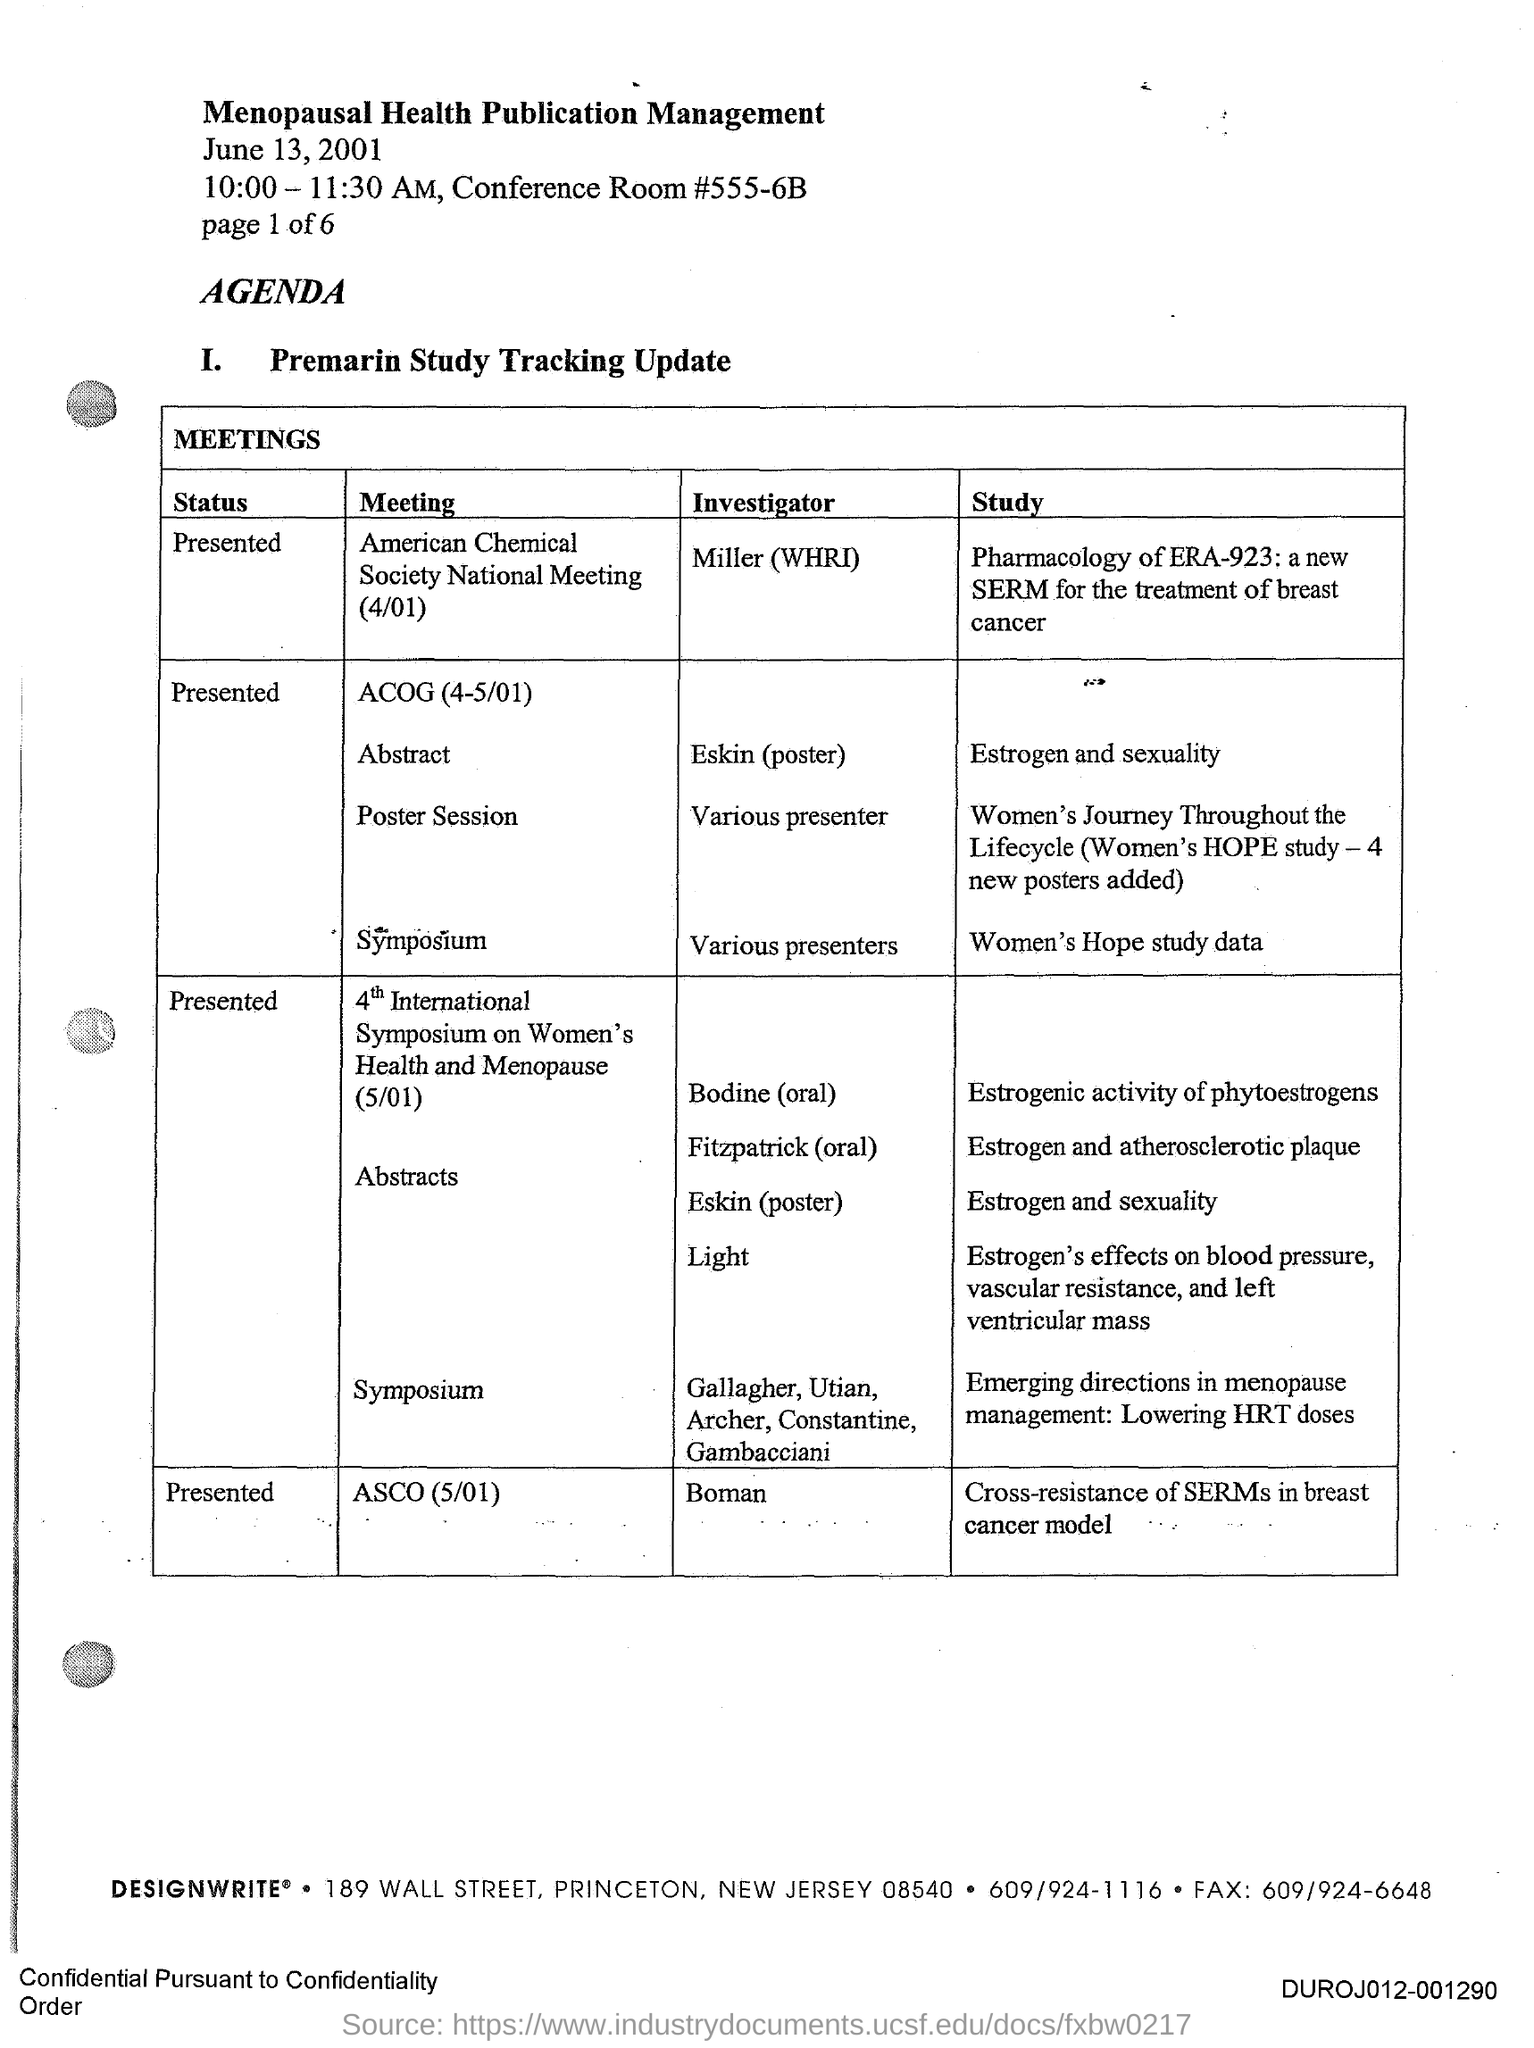Who is the investigator of the meeting ASCO(5/01)?
Provide a succinct answer. Boman. What is the title of the document?
Keep it short and to the point. Menopausal Health Publication Management. What is the status of the meeting "4th International Symposium on Women's Health and Menopause"?
Provide a succinct answer. Presented. Who is the investigator of the meeting "American Chemical Society National Meeting(4/01)"?
Your answer should be compact. Miller (WHRI). 